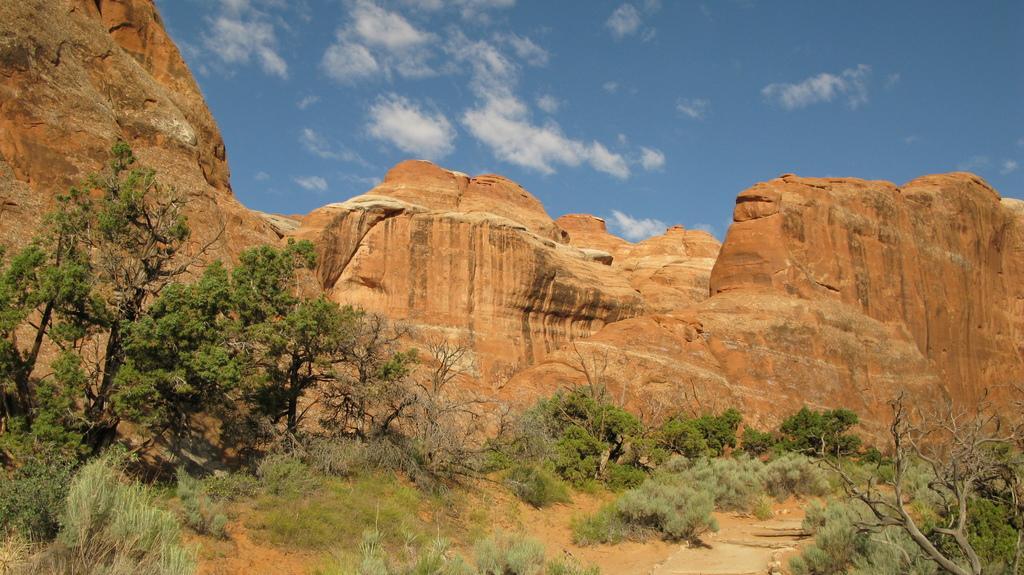In one or two sentences, can you explain what this image depicts? In this Image I can see many trees and the rock. The rock is in brown color. In the back there are clouds and the blue sky. 